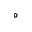<formula> <loc_0><loc_0><loc_500><loc_500>^ { \circ }</formula> 